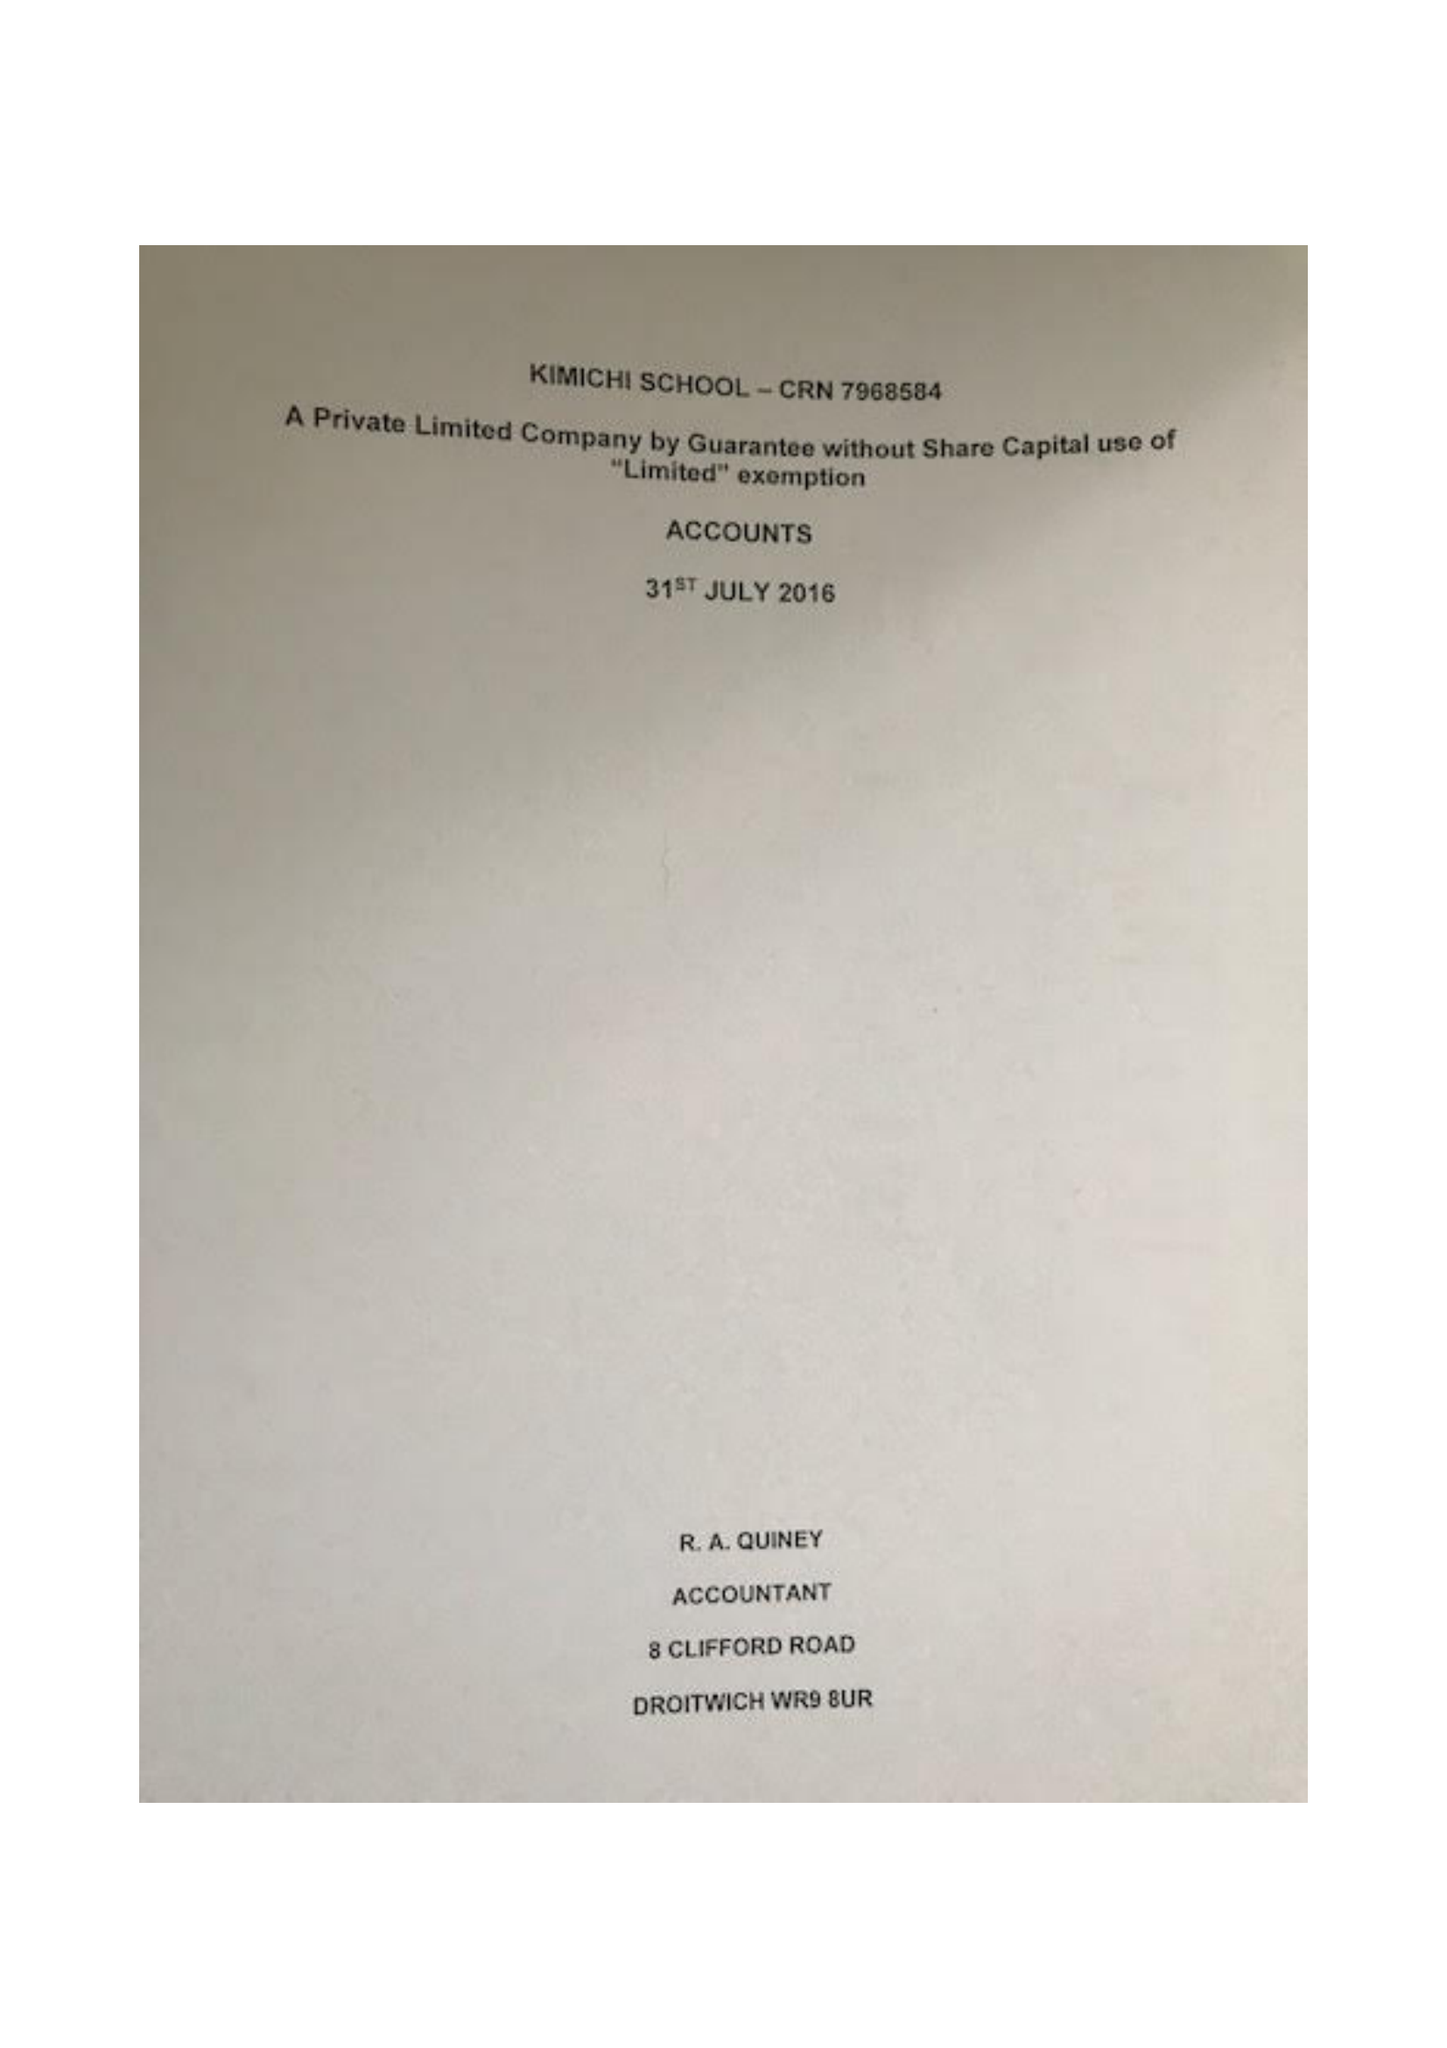What is the value for the address__post_town?
Answer the question using a single word or phrase. BIRMINGHAM 